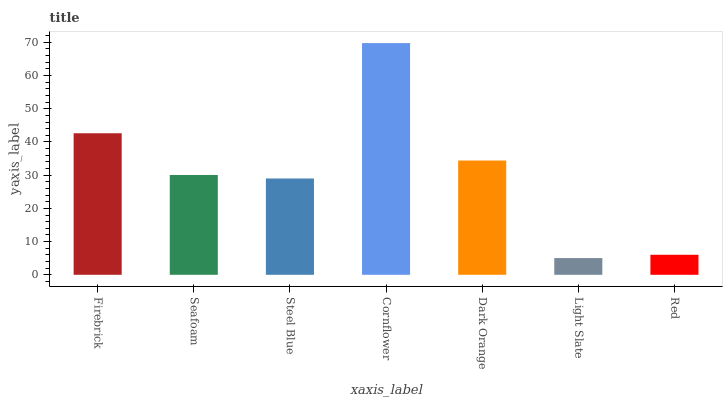Is Light Slate the minimum?
Answer yes or no. Yes. Is Cornflower the maximum?
Answer yes or no. Yes. Is Seafoam the minimum?
Answer yes or no. No. Is Seafoam the maximum?
Answer yes or no. No. Is Firebrick greater than Seafoam?
Answer yes or no. Yes. Is Seafoam less than Firebrick?
Answer yes or no. Yes. Is Seafoam greater than Firebrick?
Answer yes or no. No. Is Firebrick less than Seafoam?
Answer yes or no. No. Is Seafoam the high median?
Answer yes or no. Yes. Is Seafoam the low median?
Answer yes or no. Yes. Is Dark Orange the high median?
Answer yes or no. No. Is Light Slate the low median?
Answer yes or no. No. 